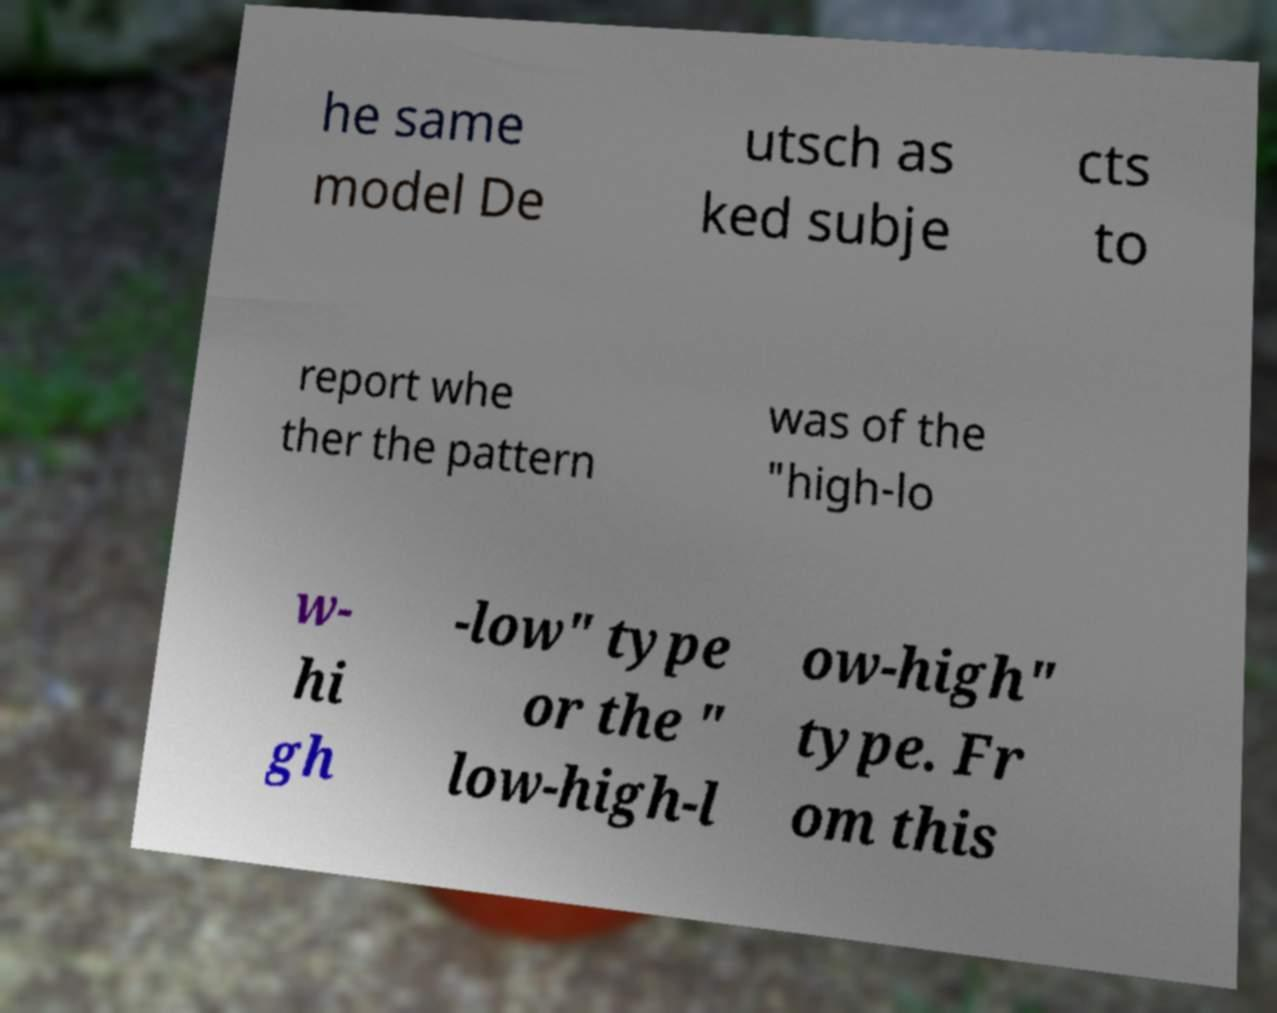There's text embedded in this image that I need extracted. Can you transcribe it verbatim? he same model De utsch as ked subje cts to report whe ther the pattern was of the "high-lo w- hi gh -low" type or the " low-high-l ow-high" type. Fr om this 